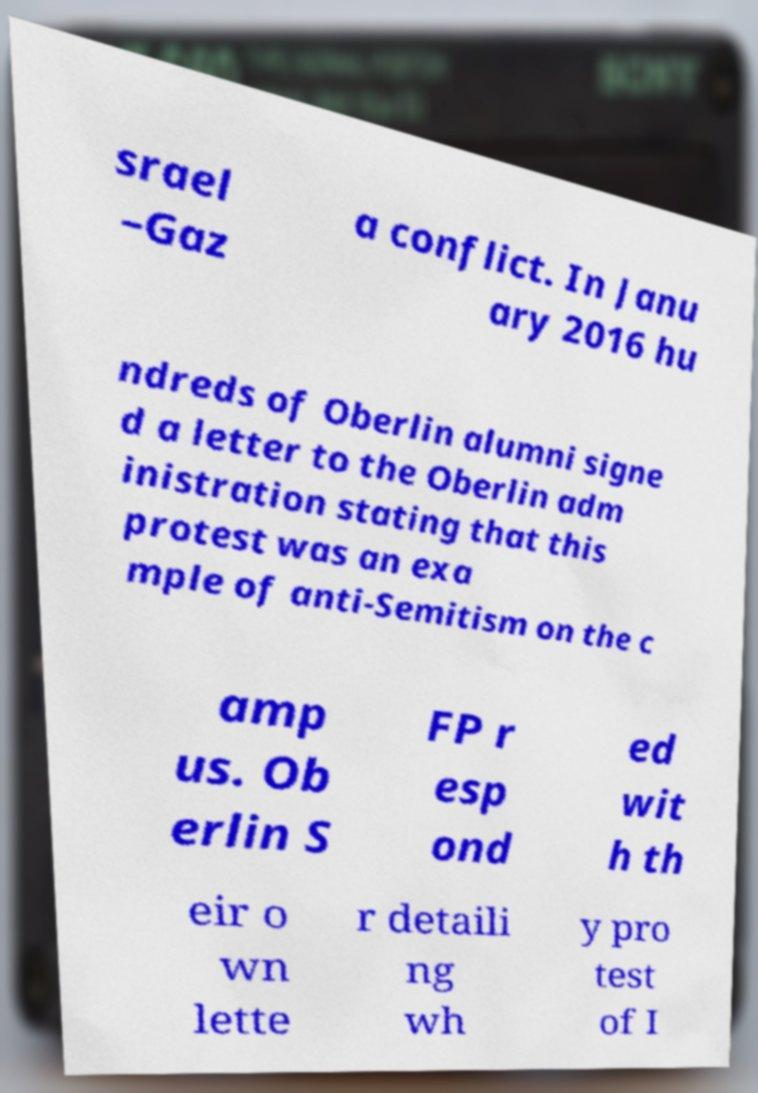Could you extract and type out the text from this image? srael –Gaz a conflict. In Janu ary 2016 hu ndreds of Oberlin alumni signe d a letter to the Oberlin adm inistration stating that this protest was an exa mple of anti-Semitism on the c amp us. Ob erlin S FP r esp ond ed wit h th eir o wn lette r detaili ng wh y pro test of I 